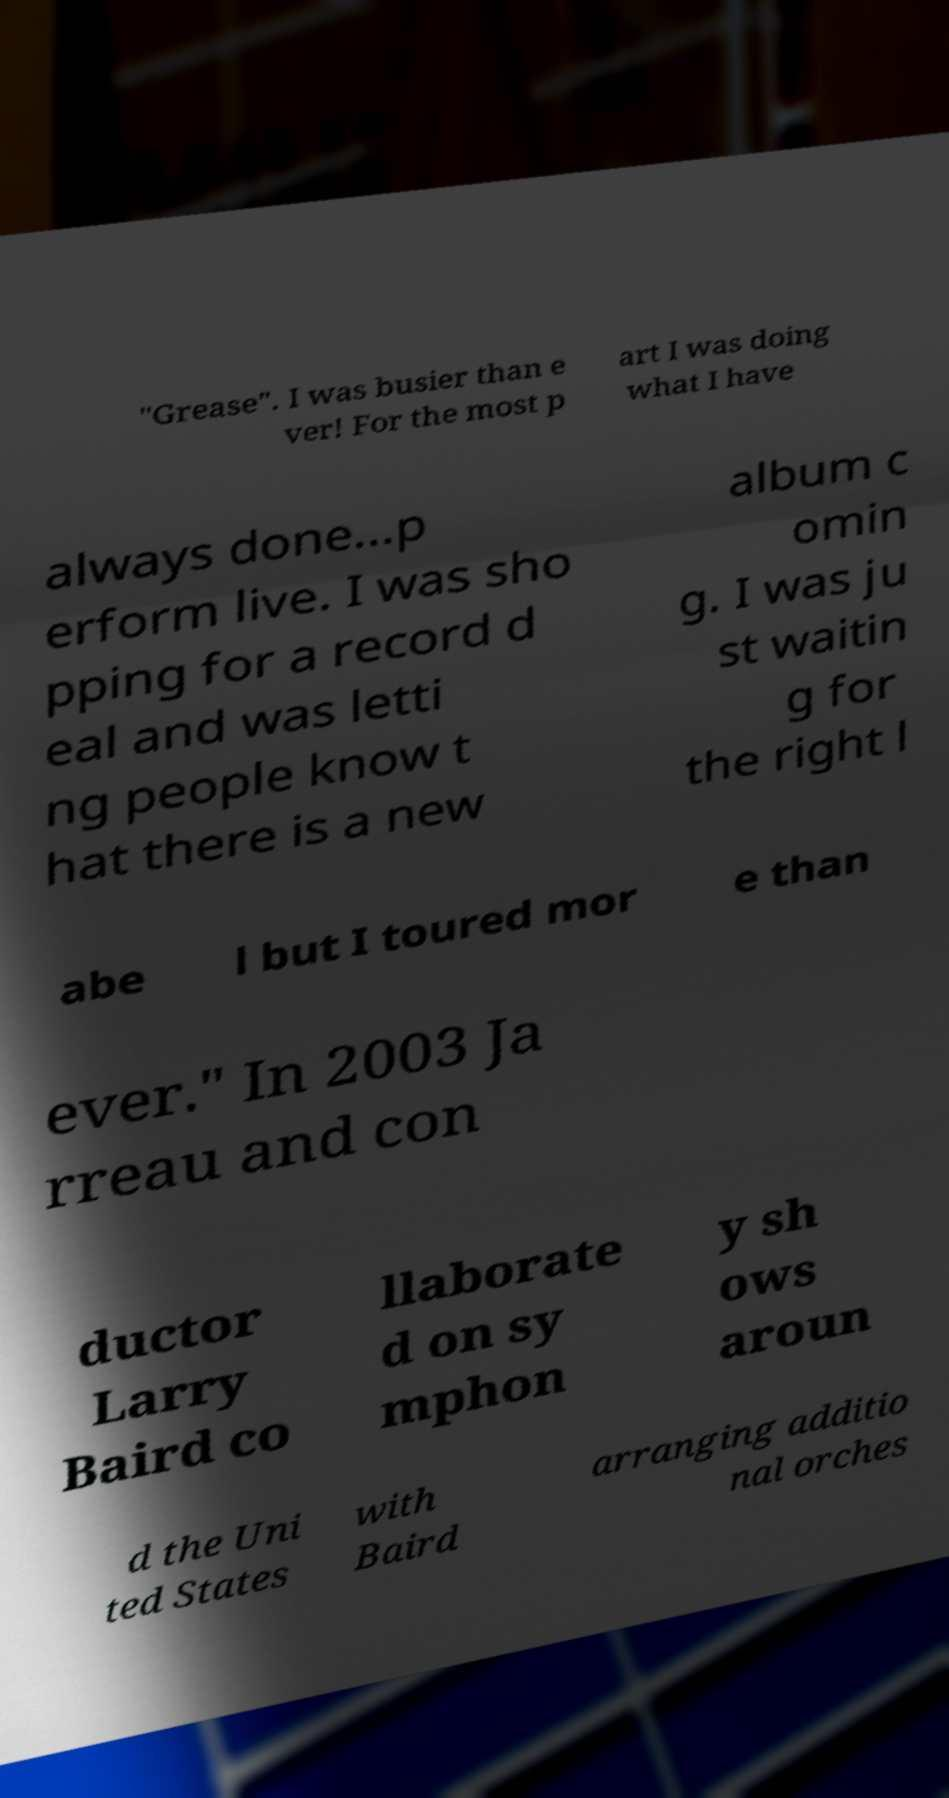For documentation purposes, I need the text within this image transcribed. Could you provide that? "Grease". I was busier than e ver! For the most p art I was doing what I have always done...p erform live. I was sho pping for a record d eal and was letti ng people know t hat there is a new album c omin g. I was ju st waitin g for the right l abe l but I toured mor e than ever." In 2003 Ja rreau and con ductor Larry Baird co llaborate d on sy mphon y sh ows aroun d the Uni ted States with Baird arranging additio nal orches 